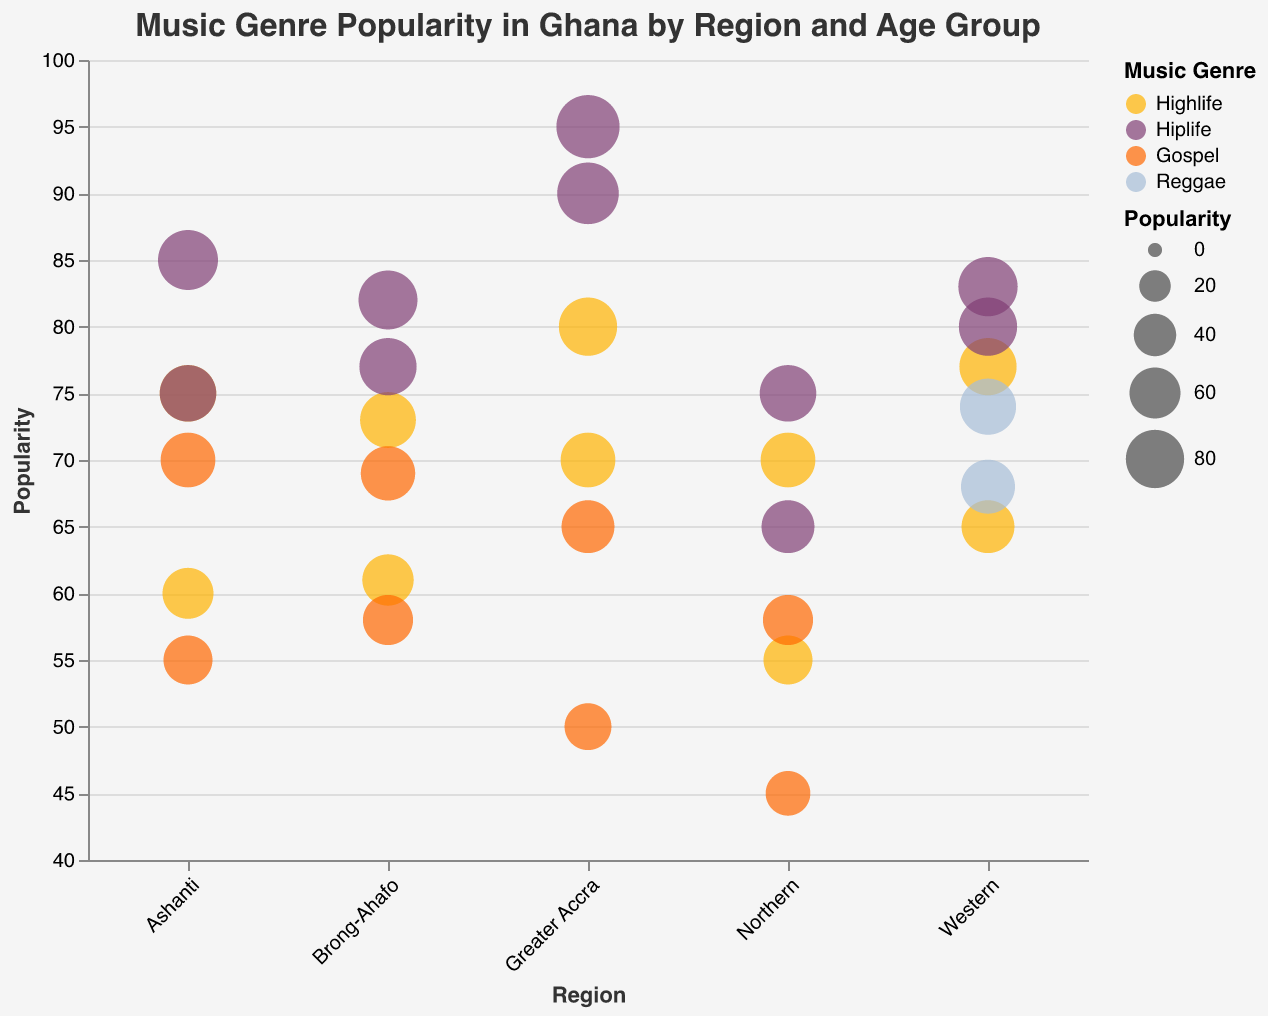What's the most popular genre in Greater Accra for the age group 18-25? To determine this, observe the bubbles corresponding to the region 'Greater Accra' and the age group '18-25'. The largest bubble indicates the highest popularity. Hiplife has a popularity of 90, which is the highest among all genres in this region and age group.
Answer: Hiplife Which region shows the highest overall popularity for the genre Gospel for age group 26-40? Examine each bubble corresponding to the genre 'Gospel' for the age group '26-40' across different regions. The largest bubble represents the highest popularity. In Greater Accra, the popularity is 65, in Ashanti, it is 70, in Brong-Ahafo, it is 69, and in Northern, it is 58. Thus, Ashanti has the highest popularity for Gospel among the 26-40 age group.
Answer: Ashanti How does the popularity of Highlife in the Northern region compare between the age groups 18-25 and 26-40? Look at the bubbles for Highlife in the Northern region for both age groups. The size of the bubbles indicates their popularity. For age group 18-25, the popularity is 55, and for age group 26-40, it is 70. Therefore, Highlife is more popular among the 26-40 age group in the Northern region.
Answer: More popular in 26-40 What's the difference in popularity for Hiplife between the Greater Accra and Brong-Ahafo regions for the age group 26-40? Identify the bubbles corresponding to Hiplife for the age group 26-40 in both regions. In Greater Accra, the popularity is 95, and in Brong-Ahafo, it is 82. The difference is 95 - 82 = 13.
Answer: 13 Which genre shows the least popularity in Ashanti for the age group 18-25? For the Ashanti region and age group 18-25, compare the popularity of different genres. Highlife has a popularity of 60, Hiplife has 75, and Gospel has 55. Gospel has the lowest popularity among these genres.
Answer: Gospel What is the average popularity of Highlife across all regions for the age group 26-40? Add the popularity values of Highlife for the age group 26-40 across all regions and divide by the number of regions. (80 + 75 + 77 + 73 + 70) / 5 = 75.
Answer: 75 How does the popularity of Reggae in the Western region for the age group 18-25 compare to Highlife in the same region and age group? Compare the bubbles for Reggae and Highlife in the Western region and age group 18-25. Reggae has a popularity of 68, while Highlife has 65. Reggae is slightly more popular than Highlife in this region and age group.
Answer: More popular What age group in Greater Accra shows a higher popularity for Gospel? Compare the bubbles for Gospel in Greater Accra for both age groups. In the 18-25 age group, the popularity is 50, and in the 26-40 age group, it is 65. The 26-40 age group has a higher popularity.
Answer: 26-40 Which region has the lowest overall popularity for Hiplife for the age group 18-25? Compare the popularity values of Hiplife for the age group 18-25 across all regions. Greater Accra has 90, Ashanti has 75, Western has 80, Brong-Ahafo has 77, and Northern has 65. Thus, Northern has the lowest popularity.
Answer: Northern 